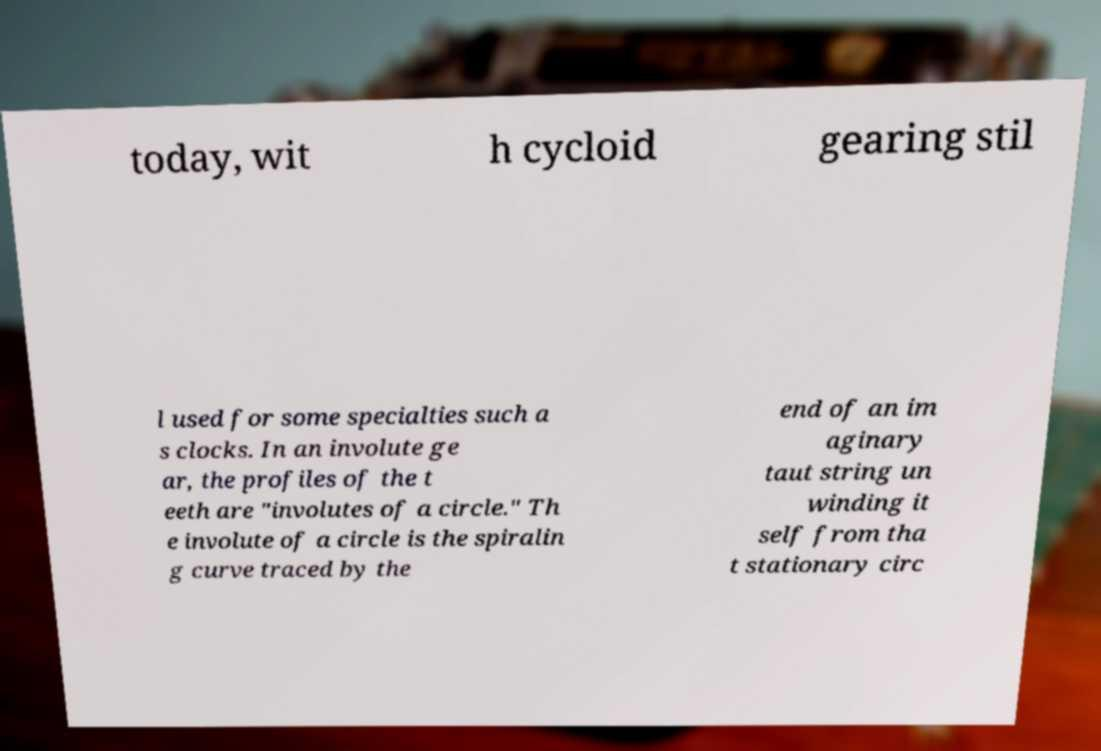Could you assist in decoding the text presented in this image and type it out clearly? today, wit h cycloid gearing stil l used for some specialties such a s clocks. In an involute ge ar, the profiles of the t eeth are "involutes of a circle." Th e involute of a circle is the spiralin g curve traced by the end of an im aginary taut string un winding it self from tha t stationary circ 